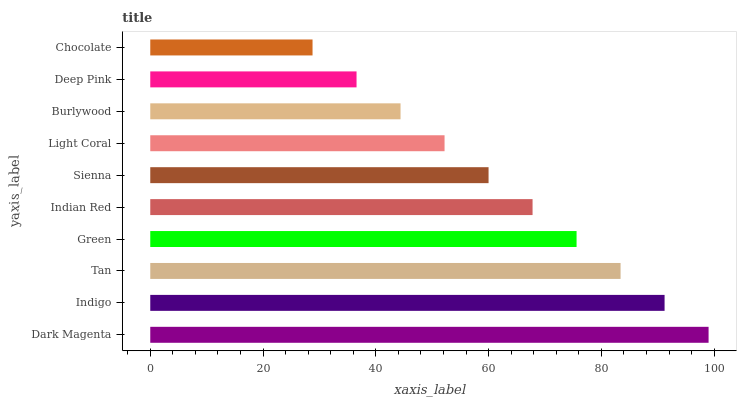Is Chocolate the minimum?
Answer yes or no. Yes. Is Dark Magenta the maximum?
Answer yes or no. Yes. Is Indigo the minimum?
Answer yes or no. No. Is Indigo the maximum?
Answer yes or no. No. Is Dark Magenta greater than Indigo?
Answer yes or no. Yes. Is Indigo less than Dark Magenta?
Answer yes or no. Yes. Is Indigo greater than Dark Magenta?
Answer yes or no. No. Is Dark Magenta less than Indigo?
Answer yes or no. No. Is Indian Red the high median?
Answer yes or no. Yes. Is Sienna the low median?
Answer yes or no. Yes. Is Tan the high median?
Answer yes or no. No. Is Indian Red the low median?
Answer yes or no. No. 